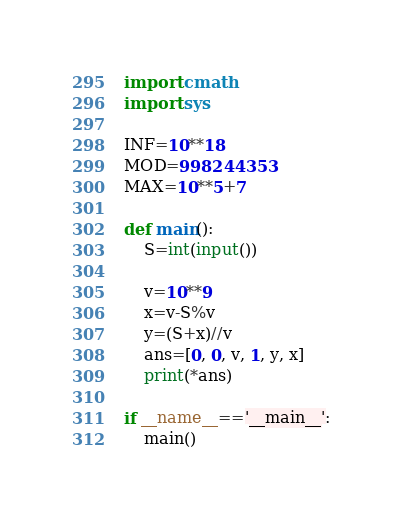<code> <loc_0><loc_0><loc_500><loc_500><_Python_>import cmath
import sys

INF=10**18
MOD=998244353
MAX=10**5+7

def main():
    S=int(input())

    v=10**9
    x=v-S%v
    y=(S+x)//v
    ans=[0, 0, v, 1, y, x]
    print(*ans)

if __name__=='__main__':
    main()
</code> 